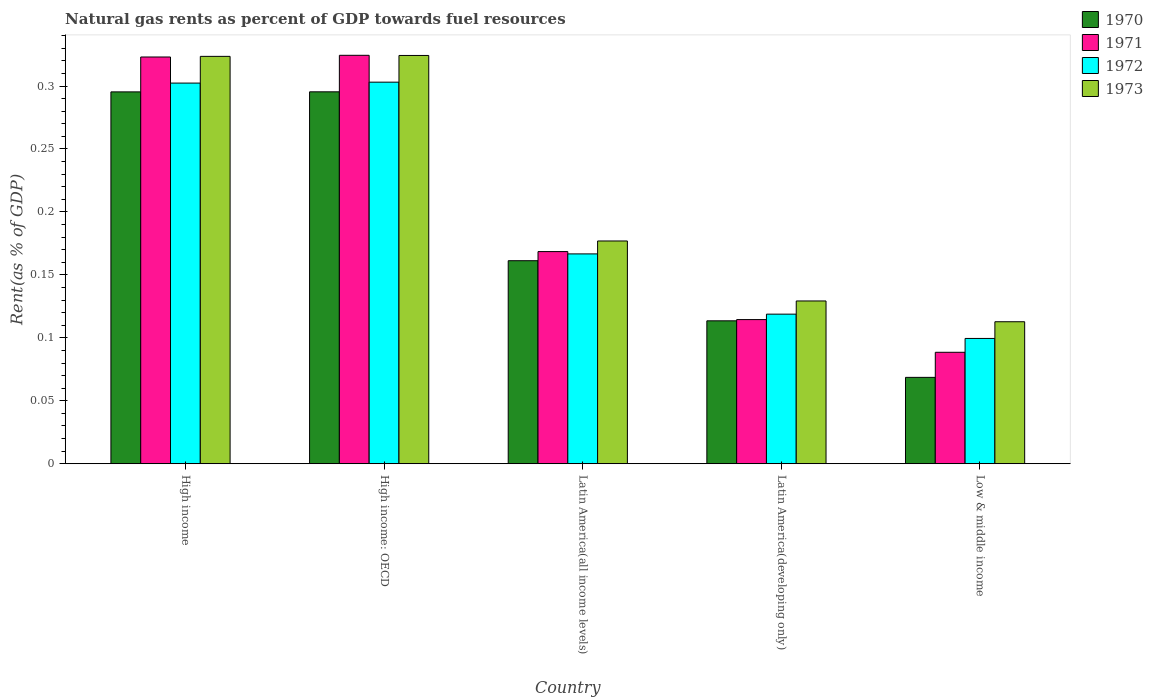How many groups of bars are there?
Offer a terse response. 5. How many bars are there on the 2nd tick from the left?
Your answer should be very brief. 4. What is the label of the 1st group of bars from the left?
Give a very brief answer. High income. What is the matural gas rent in 1971 in Low & middle income?
Ensure brevity in your answer.  0.09. Across all countries, what is the maximum matural gas rent in 1973?
Your answer should be compact. 0.32. Across all countries, what is the minimum matural gas rent in 1971?
Provide a succinct answer. 0.09. In which country was the matural gas rent in 1970 maximum?
Your answer should be very brief. High income: OECD. In which country was the matural gas rent in 1971 minimum?
Make the answer very short. Low & middle income. What is the total matural gas rent in 1973 in the graph?
Offer a terse response. 1.07. What is the difference between the matural gas rent in 1971 in Latin America(all income levels) and that in Low & middle income?
Make the answer very short. 0.08. What is the difference between the matural gas rent in 1971 in Latin America(developing only) and the matural gas rent in 1973 in Latin America(all income levels)?
Make the answer very short. -0.06. What is the average matural gas rent in 1972 per country?
Provide a short and direct response. 0.2. What is the difference between the matural gas rent of/in 1971 and matural gas rent of/in 1970 in High income: OECD?
Keep it short and to the point. 0.03. What is the ratio of the matural gas rent in 1971 in Latin America(developing only) to that in Low & middle income?
Offer a terse response. 1.29. Is the matural gas rent in 1970 in High income less than that in Latin America(all income levels)?
Offer a very short reply. No. Is the difference between the matural gas rent in 1971 in High income: OECD and Latin America(all income levels) greater than the difference between the matural gas rent in 1970 in High income: OECD and Latin America(all income levels)?
Ensure brevity in your answer.  Yes. What is the difference between the highest and the second highest matural gas rent in 1973?
Make the answer very short. 0. What is the difference between the highest and the lowest matural gas rent in 1973?
Provide a short and direct response. 0.21. Is the sum of the matural gas rent in 1972 in High income and High income: OECD greater than the maximum matural gas rent in 1970 across all countries?
Your response must be concise. Yes. Is it the case that in every country, the sum of the matural gas rent in 1973 and matural gas rent in 1972 is greater than the sum of matural gas rent in 1971 and matural gas rent in 1970?
Your answer should be compact. No. What does the 1st bar from the right in Latin America(all income levels) represents?
Ensure brevity in your answer.  1973. How many bars are there?
Keep it short and to the point. 20. How many legend labels are there?
Give a very brief answer. 4. What is the title of the graph?
Your answer should be very brief. Natural gas rents as percent of GDP towards fuel resources. What is the label or title of the Y-axis?
Give a very brief answer. Rent(as % of GDP). What is the Rent(as % of GDP) of 1970 in High income?
Your response must be concise. 0.3. What is the Rent(as % of GDP) in 1971 in High income?
Ensure brevity in your answer.  0.32. What is the Rent(as % of GDP) of 1972 in High income?
Offer a terse response. 0.3. What is the Rent(as % of GDP) in 1973 in High income?
Keep it short and to the point. 0.32. What is the Rent(as % of GDP) in 1970 in High income: OECD?
Your response must be concise. 0.3. What is the Rent(as % of GDP) of 1971 in High income: OECD?
Ensure brevity in your answer.  0.32. What is the Rent(as % of GDP) of 1972 in High income: OECD?
Ensure brevity in your answer.  0.3. What is the Rent(as % of GDP) in 1973 in High income: OECD?
Offer a very short reply. 0.32. What is the Rent(as % of GDP) of 1970 in Latin America(all income levels)?
Make the answer very short. 0.16. What is the Rent(as % of GDP) in 1971 in Latin America(all income levels)?
Your answer should be very brief. 0.17. What is the Rent(as % of GDP) in 1972 in Latin America(all income levels)?
Provide a short and direct response. 0.17. What is the Rent(as % of GDP) in 1973 in Latin America(all income levels)?
Provide a succinct answer. 0.18. What is the Rent(as % of GDP) in 1970 in Latin America(developing only)?
Give a very brief answer. 0.11. What is the Rent(as % of GDP) of 1971 in Latin America(developing only)?
Offer a very short reply. 0.11. What is the Rent(as % of GDP) of 1972 in Latin America(developing only)?
Make the answer very short. 0.12. What is the Rent(as % of GDP) of 1973 in Latin America(developing only)?
Your response must be concise. 0.13. What is the Rent(as % of GDP) in 1970 in Low & middle income?
Give a very brief answer. 0.07. What is the Rent(as % of GDP) of 1971 in Low & middle income?
Your response must be concise. 0.09. What is the Rent(as % of GDP) in 1972 in Low & middle income?
Provide a succinct answer. 0.1. What is the Rent(as % of GDP) in 1973 in Low & middle income?
Your response must be concise. 0.11. Across all countries, what is the maximum Rent(as % of GDP) of 1970?
Offer a terse response. 0.3. Across all countries, what is the maximum Rent(as % of GDP) in 1971?
Offer a terse response. 0.32. Across all countries, what is the maximum Rent(as % of GDP) of 1972?
Keep it short and to the point. 0.3. Across all countries, what is the maximum Rent(as % of GDP) in 1973?
Your response must be concise. 0.32. Across all countries, what is the minimum Rent(as % of GDP) of 1970?
Your answer should be compact. 0.07. Across all countries, what is the minimum Rent(as % of GDP) of 1971?
Your response must be concise. 0.09. Across all countries, what is the minimum Rent(as % of GDP) in 1972?
Your response must be concise. 0.1. Across all countries, what is the minimum Rent(as % of GDP) in 1973?
Your answer should be very brief. 0.11. What is the total Rent(as % of GDP) in 1970 in the graph?
Give a very brief answer. 0.93. What is the total Rent(as % of GDP) in 1971 in the graph?
Your answer should be compact. 1.02. What is the total Rent(as % of GDP) in 1972 in the graph?
Offer a very short reply. 0.99. What is the total Rent(as % of GDP) of 1973 in the graph?
Keep it short and to the point. 1.07. What is the difference between the Rent(as % of GDP) of 1971 in High income and that in High income: OECD?
Make the answer very short. -0. What is the difference between the Rent(as % of GDP) of 1972 in High income and that in High income: OECD?
Keep it short and to the point. -0. What is the difference between the Rent(as % of GDP) of 1973 in High income and that in High income: OECD?
Provide a succinct answer. -0. What is the difference between the Rent(as % of GDP) of 1970 in High income and that in Latin America(all income levels)?
Provide a short and direct response. 0.13. What is the difference between the Rent(as % of GDP) in 1971 in High income and that in Latin America(all income levels)?
Your answer should be compact. 0.15. What is the difference between the Rent(as % of GDP) of 1972 in High income and that in Latin America(all income levels)?
Your answer should be compact. 0.14. What is the difference between the Rent(as % of GDP) in 1973 in High income and that in Latin America(all income levels)?
Ensure brevity in your answer.  0.15. What is the difference between the Rent(as % of GDP) in 1970 in High income and that in Latin America(developing only)?
Ensure brevity in your answer.  0.18. What is the difference between the Rent(as % of GDP) of 1971 in High income and that in Latin America(developing only)?
Give a very brief answer. 0.21. What is the difference between the Rent(as % of GDP) of 1972 in High income and that in Latin America(developing only)?
Your response must be concise. 0.18. What is the difference between the Rent(as % of GDP) of 1973 in High income and that in Latin America(developing only)?
Your answer should be compact. 0.19. What is the difference between the Rent(as % of GDP) in 1970 in High income and that in Low & middle income?
Your response must be concise. 0.23. What is the difference between the Rent(as % of GDP) in 1971 in High income and that in Low & middle income?
Your response must be concise. 0.23. What is the difference between the Rent(as % of GDP) of 1972 in High income and that in Low & middle income?
Your answer should be very brief. 0.2. What is the difference between the Rent(as % of GDP) in 1973 in High income and that in Low & middle income?
Keep it short and to the point. 0.21. What is the difference between the Rent(as % of GDP) in 1970 in High income: OECD and that in Latin America(all income levels)?
Keep it short and to the point. 0.13. What is the difference between the Rent(as % of GDP) of 1971 in High income: OECD and that in Latin America(all income levels)?
Provide a short and direct response. 0.16. What is the difference between the Rent(as % of GDP) in 1972 in High income: OECD and that in Latin America(all income levels)?
Offer a terse response. 0.14. What is the difference between the Rent(as % of GDP) of 1973 in High income: OECD and that in Latin America(all income levels)?
Provide a succinct answer. 0.15. What is the difference between the Rent(as % of GDP) in 1970 in High income: OECD and that in Latin America(developing only)?
Provide a short and direct response. 0.18. What is the difference between the Rent(as % of GDP) in 1971 in High income: OECD and that in Latin America(developing only)?
Your answer should be very brief. 0.21. What is the difference between the Rent(as % of GDP) of 1972 in High income: OECD and that in Latin America(developing only)?
Your answer should be compact. 0.18. What is the difference between the Rent(as % of GDP) of 1973 in High income: OECD and that in Latin America(developing only)?
Your answer should be very brief. 0.2. What is the difference between the Rent(as % of GDP) of 1970 in High income: OECD and that in Low & middle income?
Your answer should be compact. 0.23. What is the difference between the Rent(as % of GDP) of 1971 in High income: OECD and that in Low & middle income?
Offer a very short reply. 0.24. What is the difference between the Rent(as % of GDP) of 1972 in High income: OECD and that in Low & middle income?
Keep it short and to the point. 0.2. What is the difference between the Rent(as % of GDP) of 1973 in High income: OECD and that in Low & middle income?
Your answer should be very brief. 0.21. What is the difference between the Rent(as % of GDP) of 1970 in Latin America(all income levels) and that in Latin America(developing only)?
Your answer should be compact. 0.05. What is the difference between the Rent(as % of GDP) in 1971 in Latin America(all income levels) and that in Latin America(developing only)?
Your answer should be very brief. 0.05. What is the difference between the Rent(as % of GDP) of 1972 in Latin America(all income levels) and that in Latin America(developing only)?
Provide a succinct answer. 0.05. What is the difference between the Rent(as % of GDP) of 1973 in Latin America(all income levels) and that in Latin America(developing only)?
Provide a short and direct response. 0.05. What is the difference between the Rent(as % of GDP) of 1970 in Latin America(all income levels) and that in Low & middle income?
Your answer should be very brief. 0.09. What is the difference between the Rent(as % of GDP) in 1971 in Latin America(all income levels) and that in Low & middle income?
Provide a succinct answer. 0.08. What is the difference between the Rent(as % of GDP) of 1972 in Latin America(all income levels) and that in Low & middle income?
Offer a terse response. 0.07. What is the difference between the Rent(as % of GDP) in 1973 in Latin America(all income levels) and that in Low & middle income?
Offer a very short reply. 0.06. What is the difference between the Rent(as % of GDP) in 1970 in Latin America(developing only) and that in Low & middle income?
Your answer should be very brief. 0.04. What is the difference between the Rent(as % of GDP) in 1971 in Latin America(developing only) and that in Low & middle income?
Provide a succinct answer. 0.03. What is the difference between the Rent(as % of GDP) in 1972 in Latin America(developing only) and that in Low & middle income?
Offer a very short reply. 0.02. What is the difference between the Rent(as % of GDP) of 1973 in Latin America(developing only) and that in Low & middle income?
Your answer should be very brief. 0.02. What is the difference between the Rent(as % of GDP) of 1970 in High income and the Rent(as % of GDP) of 1971 in High income: OECD?
Give a very brief answer. -0.03. What is the difference between the Rent(as % of GDP) in 1970 in High income and the Rent(as % of GDP) in 1972 in High income: OECD?
Provide a succinct answer. -0.01. What is the difference between the Rent(as % of GDP) of 1970 in High income and the Rent(as % of GDP) of 1973 in High income: OECD?
Your response must be concise. -0.03. What is the difference between the Rent(as % of GDP) in 1971 in High income and the Rent(as % of GDP) in 1972 in High income: OECD?
Your answer should be compact. 0.02. What is the difference between the Rent(as % of GDP) in 1971 in High income and the Rent(as % of GDP) in 1973 in High income: OECD?
Offer a very short reply. -0. What is the difference between the Rent(as % of GDP) of 1972 in High income and the Rent(as % of GDP) of 1973 in High income: OECD?
Offer a terse response. -0.02. What is the difference between the Rent(as % of GDP) of 1970 in High income and the Rent(as % of GDP) of 1971 in Latin America(all income levels)?
Give a very brief answer. 0.13. What is the difference between the Rent(as % of GDP) in 1970 in High income and the Rent(as % of GDP) in 1972 in Latin America(all income levels)?
Your response must be concise. 0.13. What is the difference between the Rent(as % of GDP) of 1970 in High income and the Rent(as % of GDP) of 1973 in Latin America(all income levels)?
Ensure brevity in your answer.  0.12. What is the difference between the Rent(as % of GDP) in 1971 in High income and the Rent(as % of GDP) in 1972 in Latin America(all income levels)?
Provide a short and direct response. 0.16. What is the difference between the Rent(as % of GDP) of 1971 in High income and the Rent(as % of GDP) of 1973 in Latin America(all income levels)?
Keep it short and to the point. 0.15. What is the difference between the Rent(as % of GDP) in 1972 in High income and the Rent(as % of GDP) in 1973 in Latin America(all income levels)?
Your response must be concise. 0.13. What is the difference between the Rent(as % of GDP) of 1970 in High income and the Rent(as % of GDP) of 1971 in Latin America(developing only)?
Offer a terse response. 0.18. What is the difference between the Rent(as % of GDP) of 1970 in High income and the Rent(as % of GDP) of 1972 in Latin America(developing only)?
Your answer should be compact. 0.18. What is the difference between the Rent(as % of GDP) in 1970 in High income and the Rent(as % of GDP) in 1973 in Latin America(developing only)?
Offer a very short reply. 0.17. What is the difference between the Rent(as % of GDP) in 1971 in High income and the Rent(as % of GDP) in 1972 in Latin America(developing only)?
Provide a succinct answer. 0.2. What is the difference between the Rent(as % of GDP) in 1971 in High income and the Rent(as % of GDP) in 1973 in Latin America(developing only)?
Provide a succinct answer. 0.19. What is the difference between the Rent(as % of GDP) of 1972 in High income and the Rent(as % of GDP) of 1973 in Latin America(developing only)?
Ensure brevity in your answer.  0.17. What is the difference between the Rent(as % of GDP) of 1970 in High income and the Rent(as % of GDP) of 1971 in Low & middle income?
Provide a short and direct response. 0.21. What is the difference between the Rent(as % of GDP) of 1970 in High income and the Rent(as % of GDP) of 1972 in Low & middle income?
Ensure brevity in your answer.  0.2. What is the difference between the Rent(as % of GDP) of 1970 in High income and the Rent(as % of GDP) of 1973 in Low & middle income?
Give a very brief answer. 0.18. What is the difference between the Rent(as % of GDP) in 1971 in High income and the Rent(as % of GDP) in 1972 in Low & middle income?
Offer a very short reply. 0.22. What is the difference between the Rent(as % of GDP) in 1971 in High income and the Rent(as % of GDP) in 1973 in Low & middle income?
Your answer should be very brief. 0.21. What is the difference between the Rent(as % of GDP) in 1972 in High income and the Rent(as % of GDP) in 1973 in Low & middle income?
Keep it short and to the point. 0.19. What is the difference between the Rent(as % of GDP) of 1970 in High income: OECD and the Rent(as % of GDP) of 1971 in Latin America(all income levels)?
Provide a short and direct response. 0.13. What is the difference between the Rent(as % of GDP) of 1970 in High income: OECD and the Rent(as % of GDP) of 1972 in Latin America(all income levels)?
Offer a very short reply. 0.13. What is the difference between the Rent(as % of GDP) of 1970 in High income: OECD and the Rent(as % of GDP) of 1973 in Latin America(all income levels)?
Keep it short and to the point. 0.12. What is the difference between the Rent(as % of GDP) in 1971 in High income: OECD and the Rent(as % of GDP) in 1972 in Latin America(all income levels)?
Your response must be concise. 0.16. What is the difference between the Rent(as % of GDP) of 1971 in High income: OECD and the Rent(as % of GDP) of 1973 in Latin America(all income levels)?
Offer a very short reply. 0.15. What is the difference between the Rent(as % of GDP) in 1972 in High income: OECD and the Rent(as % of GDP) in 1973 in Latin America(all income levels)?
Offer a terse response. 0.13. What is the difference between the Rent(as % of GDP) in 1970 in High income: OECD and the Rent(as % of GDP) in 1971 in Latin America(developing only)?
Ensure brevity in your answer.  0.18. What is the difference between the Rent(as % of GDP) in 1970 in High income: OECD and the Rent(as % of GDP) in 1972 in Latin America(developing only)?
Your answer should be compact. 0.18. What is the difference between the Rent(as % of GDP) in 1970 in High income: OECD and the Rent(as % of GDP) in 1973 in Latin America(developing only)?
Your response must be concise. 0.17. What is the difference between the Rent(as % of GDP) in 1971 in High income: OECD and the Rent(as % of GDP) in 1972 in Latin America(developing only)?
Your response must be concise. 0.21. What is the difference between the Rent(as % of GDP) of 1971 in High income: OECD and the Rent(as % of GDP) of 1973 in Latin America(developing only)?
Give a very brief answer. 0.2. What is the difference between the Rent(as % of GDP) of 1972 in High income: OECD and the Rent(as % of GDP) of 1973 in Latin America(developing only)?
Give a very brief answer. 0.17. What is the difference between the Rent(as % of GDP) in 1970 in High income: OECD and the Rent(as % of GDP) in 1971 in Low & middle income?
Ensure brevity in your answer.  0.21. What is the difference between the Rent(as % of GDP) in 1970 in High income: OECD and the Rent(as % of GDP) in 1972 in Low & middle income?
Keep it short and to the point. 0.2. What is the difference between the Rent(as % of GDP) in 1970 in High income: OECD and the Rent(as % of GDP) in 1973 in Low & middle income?
Ensure brevity in your answer.  0.18. What is the difference between the Rent(as % of GDP) in 1971 in High income: OECD and the Rent(as % of GDP) in 1972 in Low & middle income?
Ensure brevity in your answer.  0.22. What is the difference between the Rent(as % of GDP) in 1971 in High income: OECD and the Rent(as % of GDP) in 1973 in Low & middle income?
Your answer should be compact. 0.21. What is the difference between the Rent(as % of GDP) of 1972 in High income: OECD and the Rent(as % of GDP) of 1973 in Low & middle income?
Make the answer very short. 0.19. What is the difference between the Rent(as % of GDP) of 1970 in Latin America(all income levels) and the Rent(as % of GDP) of 1971 in Latin America(developing only)?
Provide a succinct answer. 0.05. What is the difference between the Rent(as % of GDP) in 1970 in Latin America(all income levels) and the Rent(as % of GDP) in 1972 in Latin America(developing only)?
Your response must be concise. 0.04. What is the difference between the Rent(as % of GDP) of 1970 in Latin America(all income levels) and the Rent(as % of GDP) of 1973 in Latin America(developing only)?
Ensure brevity in your answer.  0.03. What is the difference between the Rent(as % of GDP) of 1971 in Latin America(all income levels) and the Rent(as % of GDP) of 1972 in Latin America(developing only)?
Provide a succinct answer. 0.05. What is the difference between the Rent(as % of GDP) in 1971 in Latin America(all income levels) and the Rent(as % of GDP) in 1973 in Latin America(developing only)?
Your response must be concise. 0.04. What is the difference between the Rent(as % of GDP) in 1972 in Latin America(all income levels) and the Rent(as % of GDP) in 1973 in Latin America(developing only)?
Keep it short and to the point. 0.04. What is the difference between the Rent(as % of GDP) in 1970 in Latin America(all income levels) and the Rent(as % of GDP) in 1971 in Low & middle income?
Offer a terse response. 0.07. What is the difference between the Rent(as % of GDP) of 1970 in Latin America(all income levels) and the Rent(as % of GDP) of 1972 in Low & middle income?
Make the answer very short. 0.06. What is the difference between the Rent(as % of GDP) in 1970 in Latin America(all income levels) and the Rent(as % of GDP) in 1973 in Low & middle income?
Your answer should be very brief. 0.05. What is the difference between the Rent(as % of GDP) in 1971 in Latin America(all income levels) and the Rent(as % of GDP) in 1972 in Low & middle income?
Your response must be concise. 0.07. What is the difference between the Rent(as % of GDP) in 1971 in Latin America(all income levels) and the Rent(as % of GDP) in 1973 in Low & middle income?
Make the answer very short. 0.06. What is the difference between the Rent(as % of GDP) of 1972 in Latin America(all income levels) and the Rent(as % of GDP) of 1973 in Low & middle income?
Give a very brief answer. 0.05. What is the difference between the Rent(as % of GDP) in 1970 in Latin America(developing only) and the Rent(as % of GDP) in 1971 in Low & middle income?
Your answer should be very brief. 0.03. What is the difference between the Rent(as % of GDP) in 1970 in Latin America(developing only) and the Rent(as % of GDP) in 1972 in Low & middle income?
Offer a terse response. 0.01. What is the difference between the Rent(as % of GDP) in 1970 in Latin America(developing only) and the Rent(as % of GDP) in 1973 in Low & middle income?
Ensure brevity in your answer.  0. What is the difference between the Rent(as % of GDP) in 1971 in Latin America(developing only) and the Rent(as % of GDP) in 1972 in Low & middle income?
Give a very brief answer. 0.01. What is the difference between the Rent(as % of GDP) in 1971 in Latin America(developing only) and the Rent(as % of GDP) in 1973 in Low & middle income?
Provide a short and direct response. 0. What is the difference between the Rent(as % of GDP) of 1972 in Latin America(developing only) and the Rent(as % of GDP) of 1973 in Low & middle income?
Ensure brevity in your answer.  0.01. What is the average Rent(as % of GDP) in 1970 per country?
Offer a terse response. 0.19. What is the average Rent(as % of GDP) in 1971 per country?
Give a very brief answer. 0.2. What is the average Rent(as % of GDP) in 1972 per country?
Ensure brevity in your answer.  0.2. What is the average Rent(as % of GDP) of 1973 per country?
Provide a short and direct response. 0.21. What is the difference between the Rent(as % of GDP) in 1970 and Rent(as % of GDP) in 1971 in High income?
Provide a succinct answer. -0.03. What is the difference between the Rent(as % of GDP) in 1970 and Rent(as % of GDP) in 1972 in High income?
Ensure brevity in your answer.  -0.01. What is the difference between the Rent(as % of GDP) of 1970 and Rent(as % of GDP) of 1973 in High income?
Your response must be concise. -0.03. What is the difference between the Rent(as % of GDP) in 1971 and Rent(as % of GDP) in 1972 in High income?
Offer a very short reply. 0.02. What is the difference between the Rent(as % of GDP) of 1971 and Rent(as % of GDP) of 1973 in High income?
Provide a succinct answer. -0. What is the difference between the Rent(as % of GDP) in 1972 and Rent(as % of GDP) in 1973 in High income?
Offer a very short reply. -0.02. What is the difference between the Rent(as % of GDP) in 1970 and Rent(as % of GDP) in 1971 in High income: OECD?
Provide a short and direct response. -0.03. What is the difference between the Rent(as % of GDP) in 1970 and Rent(as % of GDP) in 1972 in High income: OECD?
Provide a succinct answer. -0.01. What is the difference between the Rent(as % of GDP) in 1970 and Rent(as % of GDP) in 1973 in High income: OECD?
Offer a terse response. -0.03. What is the difference between the Rent(as % of GDP) of 1971 and Rent(as % of GDP) of 1972 in High income: OECD?
Your answer should be compact. 0.02. What is the difference between the Rent(as % of GDP) of 1972 and Rent(as % of GDP) of 1973 in High income: OECD?
Make the answer very short. -0.02. What is the difference between the Rent(as % of GDP) of 1970 and Rent(as % of GDP) of 1971 in Latin America(all income levels)?
Offer a terse response. -0.01. What is the difference between the Rent(as % of GDP) in 1970 and Rent(as % of GDP) in 1972 in Latin America(all income levels)?
Give a very brief answer. -0.01. What is the difference between the Rent(as % of GDP) of 1970 and Rent(as % of GDP) of 1973 in Latin America(all income levels)?
Offer a very short reply. -0.02. What is the difference between the Rent(as % of GDP) of 1971 and Rent(as % of GDP) of 1972 in Latin America(all income levels)?
Offer a terse response. 0. What is the difference between the Rent(as % of GDP) in 1971 and Rent(as % of GDP) in 1973 in Latin America(all income levels)?
Your answer should be very brief. -0.01. What is the difference between the Rent(as % of GDP) in 1972 and Rent(as % of GDP) in 1973 in Latin America(all income levels)?
Provide a short and direct response. -0.01. What is the difference between the Rent(as % of GDP) of 1970 and Rent(as % of GDP) of 1971 in Latin America(developing only)?
Your answer should be compact. -0. What is the difference between the Rent(as % of GDP) of 1970 and Rent(as % of GDP) of 1972 in Latin America(developing only)?
Keep it short and to the point. -0.01. What is the difference between the Rent(as % of GDP) in 1970 and Rent(as % of GDP) in 1973 in Latin America(developing only)?
Your answer should be compact. -0.02. What is the difference between the Rent(as % of GDP) of 1971 and Rent(as % of GDP) of 1972 in Latin America(developing only)?
Your answer should be very brief. -0. What is the difference between the Rent(as % of GDP) in 1971 and Rent(as % of GDP) in 1973 in Latin America(developing only)?
Offer a terse response. -0.01. What is the difference between the Rent(as % of GDP) in 1972 and Rent(as % of GDP) in 1973 in Latin America(developing only)?
Your response must be concise. -0.01. What is the difference between the Rent(as % of GDP) of 1970 and Rent(as % of GDP) of 1971 in Low & middle income?
Provide a succinct answer. -0.02. What is the difference between the Rent(as % of GDP) in 1970 and Rent(as % of GDP) in 1972 in Low & middle income?
Provide a succinct answer. -0.03. What is the difference between the Rent(as % of GDP) in 1970 and Rent(as % of GDP) in 1973 in Low & middle income?
Your answer should be compact. -0.04. What is the difference between the Rent(as % of GDP) of 1971 and Rent(as % of GDP) of 1972 in Low & middle income?
Keep it short and to the point. -0.01. What is the difference between the Rent(as % of GDP) in 1971 and Rent(as % of GDP) in 1973 in Low & middle income?
Give a very brief answer. -0.02. What is the difference between the Rent(as % of GDP) in 1972 and Rent(as % of GDP) in 1973 in Low & middle income?
Your response must be concise. -0.01. What is the ratio of the Rent(as % of GDP) of 1970 in High income to that in High income: OECD?
Provide a short and direct response. 1. What is the ratio of the Rent(as % of GDP) in 1971 in High income to that in High income: OECD?
Your answer should be compact. 1. What is the ratio of the Rent(as % of GDP) of 1970 in High income to that in Latin America(all income levels)?
Provide a succinct answer. 1.83. What is the ratio of the Rent(as % of GDP) in 1971 in High income to that in Latin America(all income levels)?
Your answer should be very brief. 1.92. What is the ratio of the Rent(as % of GDP) of 1972 in High income to that in Latin America(all income levels)?
Ensure brevity in your answer.  1.81. What is the ratio of the Rent(as % of GDP) in 1973 in High income to that in Latin America(all income levels)?
Your answer should be very brief. 1.83. What is the ratio of the Rent(as % of GDP) of 1970 in High income to that in Latin America(developing only)?
Ensure brevity in your answer.  2.6. What is the ratio of the Rent(as % of GDP) in 1971 in High income to that in Latin America(developing only)?
Provide a succinct answer. 2.82. What is the ratio of the Rent(as % of GDP) of 1972 in High income to that in Latin America(developing only)?
Provide a succinct answer. 2.54. What is the ratio of the Rent(as % of GDP) in 1973 in High income to that in Latin America(developing only)?
Your answer should be compact. 2.5. What is the ratio of the Rent(as % of GDP) in 1970 in High income to that in Low & middle income?
Give a very brief answer. 4.31. What is the ratio of the Rent(as % of GDP) of 1971 in High income to that in Low & middle income?
Offer a terse response. 3.65. What is the ratio of the Rent(as % of GDP) in 1972 in High income to that in Low & middle income?
Make the answer very short. 3.04. What is the ratio of the Rent(as % of GDP) in 1973 in High income to that in Low & middle income?
Give a very brief answer. 2.87. What is the ratio of the Rent(as % of GDP) in 1970 in High income: OECD to that in Latin America(all income levels)?
Provide a succinct answer. 1.83. What is the ratio of the Rent(as % of GDP) in 1971 in High income: OECD to that in Latin America(all income levels)?
Provide a short and direct response. 1.93. What is the ratio of the Rent(as % of GDP) in 1972 in High income: OECD to that in Latin America(all income levels)?
Give a very brief answer. 1.82. What is the ratio of the Rent(as % of GDP) in 1973 in High income: OECD to that in Latin America(all income levels)?
Your answer should be very brief. 1.83. What is the ratio of the Rent(as % of GDP) in 1970 in High income: OECD to that in Latin America(developing only)?
Your answer should be very brief. 2.6. What is the ratio of the Rent(as % of GDP) of 1971 in High income: OECD to that in Latin America(developing only)?
Provide a short and direct response. 2.83. What is the ratio of the Rent(as % of GDP) of 1972 in High income: OECD to that in Latin America(developing only)?
Offer a terse response. 2.55. What is the ratio of the Rent(as % of GDP) in 1973 in High income: OECD to that in Latin America(developing only)?
Offer a terse response. 2.51. What is the ratio of the Rent(as % of GDP) of 1970 in High income: OECD to that in Low & middle income?
Provide a short and direct response. 4.31. What is the ratio of the Rent(as % of GDP) of 1971 in High income: OECD to that in Low & middle income?
Provide a short and direct response. 3.66. What is the ratio of the Rent(as % of GDP) in 1972 in High income: OECD to that in Low & middle income?
Provide a succinct answer. 3.05. What is the ratio of the Rent(as % of GDP) in 1973 in High income: OECD to that in Low & middle income?
Give a very brief answer. 2.88. What is the ratio of the Rent(as % of GDP) in 1970 in Latin America(all income levels) to that in Latin America(developing only)?
Your answer should be very brief. 1.42. What is the ratio of the Rent(as % of GDP) of 1971 in Latin America(all income levels) to that in Latin America(developing only)?
Your answer should be compact. 1.47. What is the ratio of the Rent(as % of GDP) in 1972 in Latin America(all income levels) to that in Latin America(developing only)?
Ensure brevity in your answer.  1.4. What is the ratio of the Rent(as % of GDP) of 1973 in Latin America(all income levels) to that in Latin America(developing only)?
Give a very brief answer. 1.37. What is the ratio of the Rent(as % of GDP) in 1970 in Latin America(all income levels) to that in Low & middle income?
Your answer should be very brief. 2.35. What is the ratio of the Rent(as % of GDP) in 1971 in Latin America(all income levels) to that in Low & middle income?
Make the answer very short. 1.9. What is the ratio of the Rent(as % of GDP) of 1972 in Latin America(all income levels) to that in Low & middle income?
Provide a succinct answer. 1.67. What is the ratio of the Rent(as % of GDP) of 1973 in Latin America(all income levels) to that in Low & middle income?
Keep it short and to the point. 1.57. What is the ratio of the Rent(as % of GDP) in 1970 in Latin America(developing only) to that in Low & middle income?
Ensure brevity in your answer.  1.65. What is the ratio of the Rent(as % of GDP) in 1971 in Latin America(developing only) to that in Low & middle income?
Keep it short and to the point. 1.29. What is the ratio of the Rent(as % of GDP) of 1972 in Latin America(developing only) to that in Low & middle income?
Keep it short and to the point. 1.19. What is the ratio of the Rent(as % of GDP) in 1973 in Latin America(developing only) to that in Low & middle income?
Provide a short and direct response. 1.15. What is the difference between the highest and the second highest Rent(as % of GDP) in 1971?
Offer a very short reply. 0. What is the difference between the highest and the second highest Rent(as % of GDP) in 1972?
Your answer should be compact. 0. What is the difference between the highest and the second highest Rent(as % of GDP) of 1973?
Ensure brevity in your answer.  0. What is the difference between the highest and the lowest Rent(as % of GDP) in 1970?
Your response must be concise. 0.23. What is the difference between the highest and the lowest Rent(as % of GDP) of 1971?
Give a very brief answer. 0.24. What is the difference between the highest and the lowest Rent(as % of GDP) of 1972?
Ensure brevity in your answer.  0.2. What is the difference between the highest and the lowest Rent(as % of GDP) in 1973?
Ensure brevity in your answer.  0.21. 